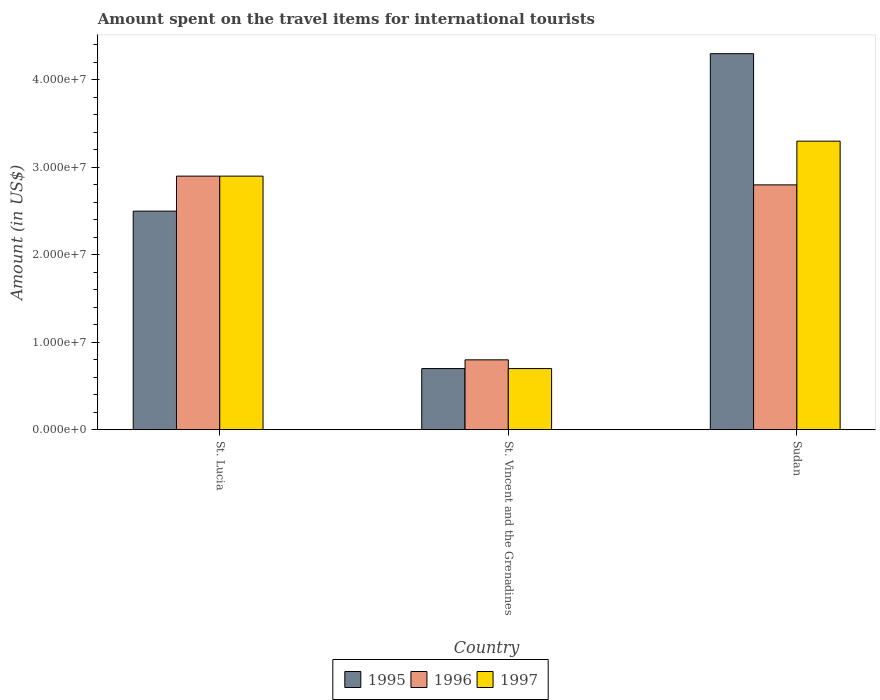How many different coloured bars are there?
Provide a short and direct response. 3. How many groups of bars are there?
Provide a succinct answer. 3. Are the number of bars per tick equal to the number of legend labels?
Your response must be concise. Yes. How many bars are there on the 3rd tick from the left?
Keep it short and to the point. 3. How many bars are there on the 3rd tick from the right?
Provide a short and direct response. 3. What is the label of the 1st group of bars from the left?
Offer a terse response. St. Lucia. What is the amount spent on the travel items for international tourists in 1996 in St. Lucia?
Your response must be concise. 2.90e+07. Across all countries, what is the maximum amount spent on the travel items for international tourists in 1996?
Your answer should be very brief. 2.90e+07. Across all countries, what is the minimum amount spent on the travel items for international tourists in 1997?
Offer a terse response. 7.00e+06. In which country was the amount spent on the travel items for international tourists in 1997 maximum?
Provide a short and direct response. Sudan. In which country was the amount spent on the travel items for international tourists in 1995 minimum?
Your answer should be compact. St. Vincent and the Grenadines. What is the total amount spent on the travel items for international tourists in 1995 in the graph?
Provide a short and direct response. 7.50e+07. What is the difference between the amount spent on the travel items for international tourists in 1997 in St. Lucia and that in Sudan?
Keep it short and to the point. -4.00e+06. What is the difference between the amount spent on the travel items for international tourists in 1997 in St. Lucia and the amount spent on the travel items for international tourists in 1995 in St. Vincent and the Grenadines?
Your answer should be very brief. 2.20e+07. What is the average amount spent on the travel items for international tourists in 1996 per country?
Offer a very short reply. 2.17e+07. What is the difference between the amount spent on the travel items for international tourists of/in 1997 and amount spent on the travel items for international tourists of/in 1996 in Sudan?
Offer a very short reply. 5.00e+06. What is the ratio of the amount spent on the travel items for international tourists in 1996 in St. Vincent and the Grenadines to that in Sudan?
Make the answer very short. 0.29. What is the difference between the highest and the second highest amount spent on the travel items for international tourists in 1995?
Your response must be concise. 1.80e+07. What is the difference between the highest and the lowest amount spent on the travel items for international tourists in 1996?
Offer a very short reply. 2.10e+07. In how many countries, is the amount spent on the travel items for international tourists in 1997 greater than the average amount spent on the travel items for international tourists in 1997 taken over all countries?
Provide a succinct answer. 2. What does the 2nd bar from the right in St. Lucia represents?
Provide a succinct answer. 1996. Is it the case that in every country, the sum of the amount spent on the travel items for international tourists in 1995 and amount spent on the travel items for international tourists in 1996 is greater than the amount spent on the travel items for international tourists in 1997?
Your response must be concise. Yes. How many bars are there?
Offer a terse response. 9. Are all the bars in the graph horizontal?
Offer a terse response. No. What is the difference between two consecutive major ticks on the Y-axis?
Keep it short and to the point. 1.00e+07. Does the graph contain any zero values?
Offer a terse response. No. Does the graph contain grids?
Your answer should be compact. No. Where does the legend appear in the graph?
Ensure brevity in your answer.  Bottom center. How many legend labels are there?
Provide a succinct answer. 3. What is the title of the graph?
Ensure brevity in your answer.  Amount spent on the travel items for international tourists. Does "1969" appear as one of the legend labels in the graph?
Offer a very short reply. No. What is the label or title of the Y-axis?
Provide a short and direct response. Amount (in US$). What is the Amount (in US$) of 1995 in St. Lucia?
Ensure brevity in your answer.  2.50e+07. What is the Amount (in US$) of 1996 in St. Lucia?
Provide a short and direct response. 2.90e+07. What is the Amount (in US$) of 1997 in St. Lucia?
Your answer should be very brief. 2.90e+07. What is the Amount (in US$) in 1995 in St. Vincent and the Grenadines?
Make the answer very short. 7.00e+06. What is the Amount (in US$) in 1996 in St. Vincent and the Grenadines?
Your answer should be compact. 8.00e+06. What is the Amount (in US$) of 1997 in St. Vincent and the Grenadines?
Give a very brief answer. 7.00e+06. What is the Amount (in US$) of 1995 in Sudan?
Give a very brief answer. 4.30e+07. What is the Amount (in US$) in 1996 in Sudan?
Keep it short and to the point. 2.80e+07. What is the Amount (in US$) in 1997 in Sudan?
Your response must be concise. 3.30e+07. Across all countries, what is the maximum Amount (in US$) of 1995?
Keep it short and to the point. 4.30e+07. Across all countries, what is the maximum Amount (in US$) in 1996?
Your answer should be very brief. 2.90e+07. Across all countries, what is the maximum Amount (in US$) of 1997?
Offer a terse response. 3.30e+07. Across all countries, what is the minimum Amount (in US$) in 1995?
Offer a very short reply. 7.00e+06. What is the total Amount (in US$) in 1995 in the graph?
Provide a succinct answer. 7.50e+07. What is the total Amount (in US$) in 1996 in the graph?
Your response must be concise. 6.50e+07. What is the total Amount (in US$) in 1997 in the graph?
Your response must be concise. 6.90e+07. What is the difference between the Amount (in US$) in 1995 in St. Lucia and that in St. Vincent and the Grenadines?
Provide a short and direct response. 1.80e+07. What is the difference between the Amount (in US$) of 1996 in St. Lucia and that in St. Vincent and the Grenadines?
Your response must be concise. 2.10e+07. What is the difference between the Amount (in US$) of 1997 in St. Lucia and that in St. Vincent and the Grenadines?
Keep it short and to the point. 2.20e+07. What is the difference between the Amount (in US$) of 1995 in St. Lucia and that in Sudan?
Your answer should be very brief. -1.80e+07. What is the difference between the Amount (in US$) in 1996 in St. Lucia and that in Sudan?
Your answer should be compact. 1.00e+06. What is the difference between the Amount (in US$) in 1995 in St. Vincent and the Grenadines and that in Sudan?
Your answer should be very brief. -3.60e+07. What is the difference between the Amount (in US$) in 1996 in St. Vincent and the Grenadines and that in Sudan?
Make the answer very short. -2.00e+07. What is the difference between the Amount (in US$) of 1997 in St. Vincent and the Grenadines and that in Sudan?
Offer a terse response. -2.60e+07. What is the difference between the Amount (in US$) of 1995 in St. Lucia and the Amount (in US$) of 1996 in St. Vincent and the Grenadines?
Your answer should be very brief. 1.70e+07. What is the difference between the Amount (in US$) of 1995 in St. Lucia and the Amount (in US$) of 1997 in St. Vincent and the Grenadines?
Make the answer very short. 1.80e+07. What is the difference between the Amount (in US$) in 1996 in St. Lucia and the Amount (in US$) in 1997 in St. Vincent and the Grenadines?
Ensure brevity in your answer.  2.20e+07. What is the difference between the Amount (in US$) of 1995 in St. Lucia and the Amount (in US$) of 1997 in Sudan?
Your answer should be very brief. -8.00e+06. What is the difference between the Amount (in US$) of 1995 in St. Vincent and the Grenadines and the Amount (in US$) of 1996 in Sudan?
Your answer should be very brief. -2.10e+07. What is the difference between the Amount (in US$) in 1995 in St. Vincent and the Grenadines and the Amount (in US$) in 1997 in Sudan?
Provide a short and direct response. -2.60e+07. What is the difference between the Amount (in US$) of 1996 in St. Vincent and the Grenadines and the Amount (in US$) of 1997 in Sudan?
Keep it short and to the point. -2.50e+07. What is the average Amount (in US$) in 1995 per country?
Provide a short and direct response. 2.50e+07. What is the average Amount (in US$) of 1996 per country?
Give a very brief answer. 2.17e+07. What is the average Amount (in US$) of 1997 per country?
Provide a short and direct response. 2.30e+07. What is the difference between the Amount (in US$) of 1995 and Amount (in US$) of 1996 in St. Lucia?
Provide a succinct answer. -4.00e+06. What is the difference between the Amount (in US$) in 1995 and Amount (in US$) in 1997 in St. Lucia?
Your answer should be compact. -4.00e+06. What is the difference between the Amount (in US$) in 1996 and Amount (in US$) in 1997 in St. Lucia?
Your answer should be compact. 0. What is the difference between the Amount (in US$) of 1996 and Amount (in US$) of 1997 in St. Vincent and the Grenadines?
Your answer should be compact. 1.00e+06. What is the difference between the Amount (in US$) in 1995 and Amount (in US$) in 1996 in Sudan?
Make the answer very short. 1.50e+07. What is the difference between the Amount (in US$) in 1995 and Amount (in US$) in 1997 in Sudan?
Offer a terse response. 1.00e+07. What is the difference between the Amount (in US$) of 1996 and Amount (in US$) of 1997 in Sudan?
Give a very brief answer. -5.00e+06. What is the ratio of the Amount (in US$) of 1995 in St. Lucia to that in St. Vincent and the Grenadines?
Ensure brevity in your answer.  3.57. What is the ratio of the Amount (in US$) of 1996 in St. Lucia to that in St. Vincent and the Grenadines?
Offer a very short reply. 3.62. What is the ratio of the Amount (in US$) in 1997 in St. Lucia to that in St. Vincent and the Grenadines?
Provide a succinct answer. 4.14. What is the ratio of the Amount (in US$) of 1995 in St. Lucia to that in Sudan?
Keep it short and to the point. 0.58. What is the ratio of the Amount (in US$) of 1996 in St. Lucia to that in Sudan?
Provide a succinct answer. 1.04. What is the ratio of the Amount (in US$) in 1997 in St. Lucia to that in Sudan?
Keep it short and to the point. 0.88. What is the ratio of the Amount (in US$) of 1995 in St. Vincent and the Grenadines to that in Sudan?
Provide a succinct answer. 0.16. What is the ratio of the Amount (in US$) in 1996 in St. Vincent and the Grenadines to that in Sudan?
Ensure brevity in your answer.  0.29. What is the ratio of the Amount (in US$) in 1997 in St. Vincent and the Grenadines to that in Sudan?
Make the answer very short. 0.21. What is the difference between the highest and the second highest Amount (in US$) of 1995?
Your response must be concise. 1.80e+07. What is the difference between the highest and the second highest Amount (in US$) of 1996?
Your response must be concise. 1.00e+06. What is the difference between the highest and the second highest Amount (in US$) of 1997?
Ensure brevity in your answer.  4.00e+06. What is the difference between the highest and the lowest Amount (in US$) of 1995?
Your response must be concise. 3.60e+07. What is the difference between the highest and the lowest Amount (in US$) of 1996?
Keep it short and to the point. 2.10e+07. What is the difference between the highest and the lowest Amount (in US$) in 1997?
Your response must be concise. 2.60e+07. 